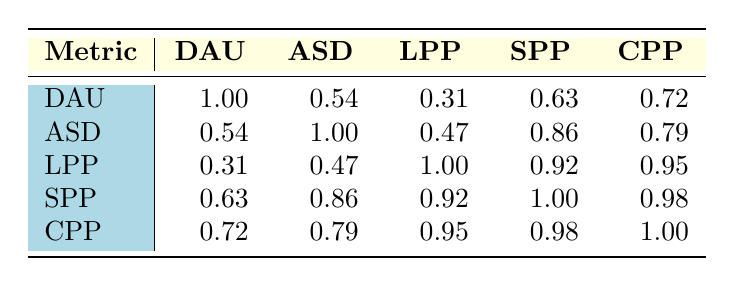What is the correlation between daily active users and average session duration? The table shows a correlation value of 0.54 between daily active users and average session duration, indicating a moderate positive relationship between the two metrics.
Answer: 0.54 Which platform has the highest likes per post? Based on the table, Instagram has the highest likes per post with a value of 250.
Answer: 250 Is there a strong correlation between shares per post and comments per post? The correlation value between shares per post (SPP) and comments per post (CPP) is 0.98, indicating a very strong positive correlation between these two metrics.
Answer: Yes What is the average session duration across all platforms listed in the table? The average session duration can be calculated by adding the average session duration values and dividing by the number of platforms: (58 + 30 + 20 + 52 + 25) / 5 = 37
Answer: 37 Which metric has the strongest correlation with likes per post? By examining the correlation values, comments per post (CPP) has the strongest correlation with likes per post (LPP) at 0.95, suggesting that they tend to increase together more than with other metrics.
Answer: Comments per post Is Instagram's daily active users higher than TikTok's? The table shows that Instagram has 1,200,000,000 daily active users, while TikTok has 1,000,000,000. Hence, Instagram's daily active users are higher.
Answer: Yes What is the difference in correlations between average session duration and shares per post? The correlation between average session duration (ASD) and shares per post (SPP) is 0.86, and nothing else in the table has a higher difference to compare, but the direct correlation is already strong and positive.
Answer: 0.86 How many metrics are correlated with a value over 0.90? By analyzing the correlation values in the table, four pairs have correlation values over 0.90: shares per post with comments per post, likes per post with shares per post, likes per post with comments per post, and daily active users with average session duration.
Answer: 4 What is the sum of the likes per post for Facebook and LinkedIn? For Facebook, the likes per post is 150, and for LinkedIn, it is 50. Adding these two gives 150 + 50 = 200.
Answer: 200 